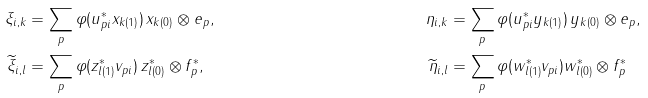Convert formula to latex. <formula><loc_0><loc_0><loc_500><loc_500>\xi _ { i , k } & = \sum _ { p } \varphi ( u _ { p i } ^ { * } x _ { k ( 1 ) } ) \, x _ { k ( 0 ) } \otimes e _ { p } , & \eta _ { i , k } & = \sum _ { p } \varphi ( u _ { p i } ^ { * } y _ { k ( 1 ) } ) \, y _ { k ( 0 ) } \otimes e _ { p } , \\ \widetilde { \xi } _ { i , l } & = \sum _ { p } \varphi ( z _ { l ( 1 ) } ^ { * } v _ { p i } ) \, z _ { l ( 0 ) } ^ { * } \otimes f _ { p } ^ { * } , & \widetilde { \eta } _ { i , l } & = \sum _ { p } \varphi ( w _ { l ( 1 ) } ^ { * } v _ { p i } ) w _ { l ( 0 ) } ^ { * } \otimes f _ { p } ^ { * }</formula> 